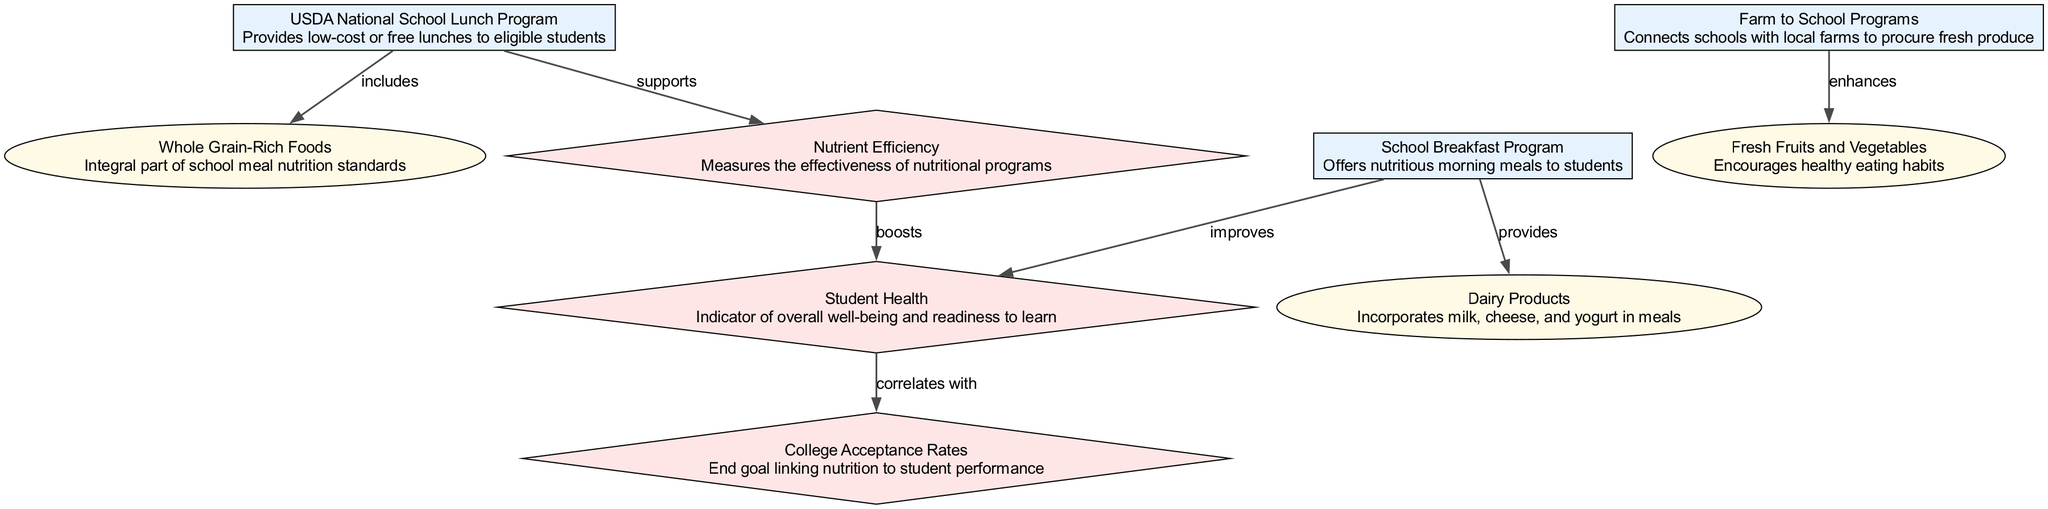What program provides low-cost or free lunches? The diagram indicates that the "USDA National School Lunch Program" is the program that provides low-cost or free lunches to eligible students. This can be found directly in the description linked to that node.
Answer: USDA National School Lunch Program What food is integral to school meal nutrition standards? According to the diagram, "Whole Grain-Rich Foods" are highlighted as an integral part of school meal nutrition standards which is shown as a direct link in the illustration.
Answer: Whole Grain-Rich Foods How many metrics are shown in the diagram? The diagram displays three metrics: "Nutrient Efficiency," "Student Health," and "College Acceptance Rates." Counting each of these nodes indicates the total of three metrics represented.
Answer: 3 Which program enhances the consumption of fresh produce? The "Farm to School Programs" is the program that is specifically noted to enhance the consumption of "Fresh Fruits and Vegetables" as indicated by the edge connecting those two nodes.
Answer: Farm to School Programs What is the relationship between student health and college acceptance rates? The diagram outlines that "Student Health" directly correlates with "College Acceptance Rates," which suggests a positive influence from one to the other as shown by the connecting edge labeled "correlates with."
Answer: correlates with What type of food does the School Breakfast Program provide? The "School Breakfast Program" is associated with providing "Dairy Products" according to the directed edge from the program to the food in the diagram, specifying its contributions to student meals.
Answer: Dairy Products What supports nutrient efficiency in K-12 schools? The "USDA National School Lunch Program" is depicted as supporting "Nutrient Efficiency" in the diagram, making it clear that this program has a role in enhancing the nutritional effectiveness of meals provided.
Answer: USDA National School Lunch Program Which metric measures the effectiveness of nutritional programs? "Nutrient Efficiency" is labeled as the metric that measures the effectiveness of nutritional programs clearly indicated in the metric's node description.
Answer: Nutrient Efficiency What type of relationship exists between whole grain-rich foods and the USDA National School Lunch Program? The relationship is defined as "includes," showing that the program incorporates whole grain-rich foods into its meal offerings as explicitly indicated in the diagram.
Answer: includes 